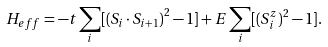Convert formula to latex. <formula><loc_0><loc_0><loc_500><loc_500>H _ { e f f } = - t \sum _ { i } [ \left ( { S } _ { i } \cdot { S } _ { i + 1 } \right ) ^ { 2 } - 1 ] + E \sum _ { i } [ ( S _ { i } ^ { z } ) ^ { 2 } - 1 ] .</formula> 